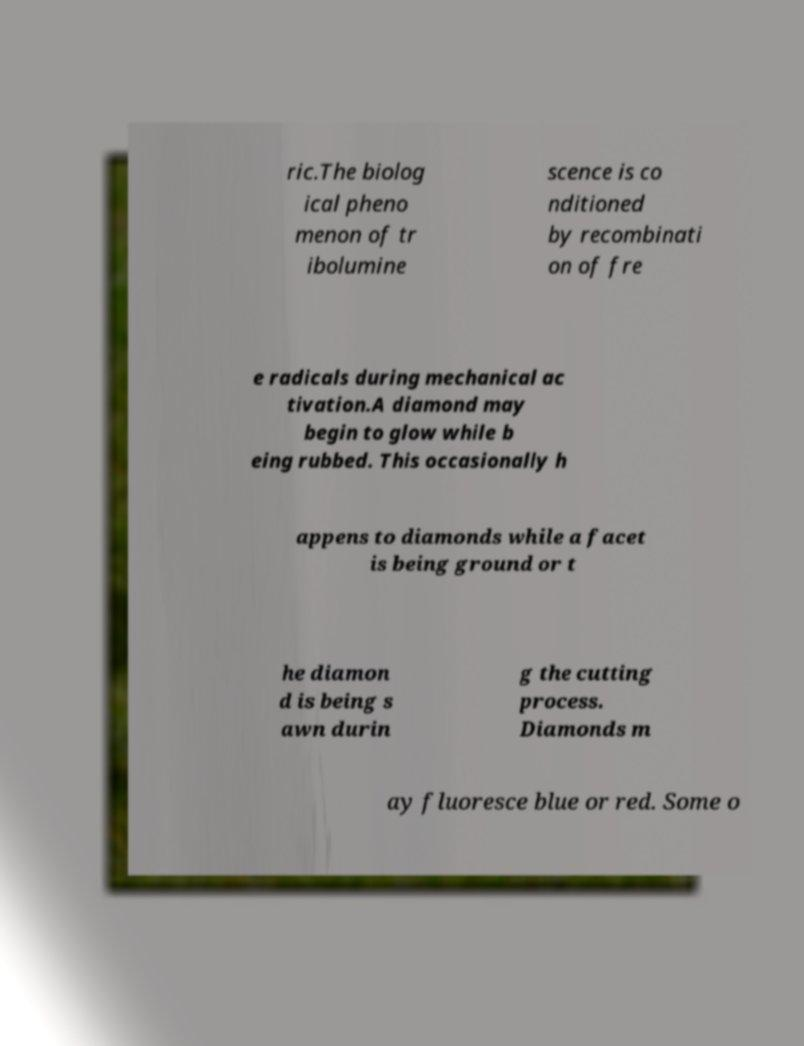For documentation purposes, I need the text within this image transcribed. Could you provide that? ric.The biolog ical pheno menon of tr ibolumine scence is co nditioned by recombinati on of fre e radicals during mechanical ac tivation.A diamond may begin to glow while b eing rubbed. This occasionally h appens to diamonds while a facet is being ground or t he diamon d is being s awn durin g the cutting process. Diamonds m ay fluoresce blue or red. Some o 